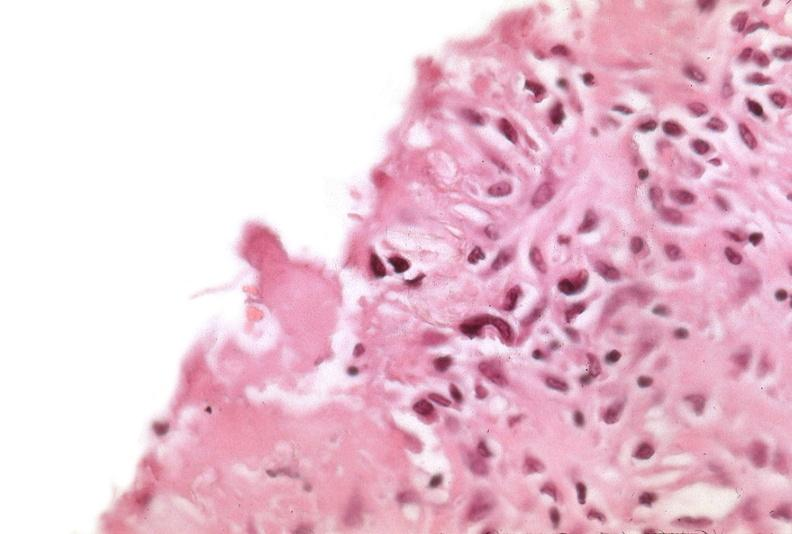what is present?
Answer the question using a single word or phrase. Respiratory 